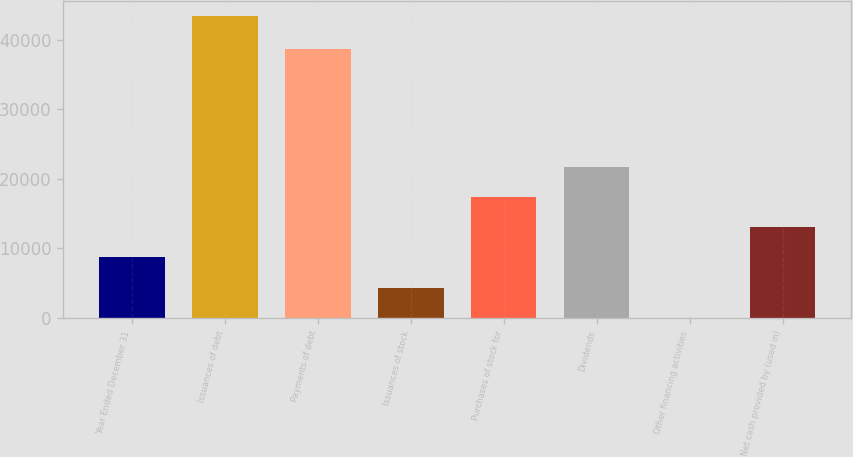Convert chart. <chart><loc_0><loc_0><loc_500><loc_500><bar_chart><fcel>Year Ended December 31<fcel>Issuances of debt<fcel>Payments of debt<fcel>Issuances of stock<fcel>Purchases of stock for<fcel>Dividends<fcel>Other financing activities<fcel>Net cash provided by (used in)<nl><fcel>8698.6<fcel>43425<fcel>38714<fcel>4357.8<fcel>17380.2<fcel>21721<fcel>17<fcel>13039.4<nl></chart> 